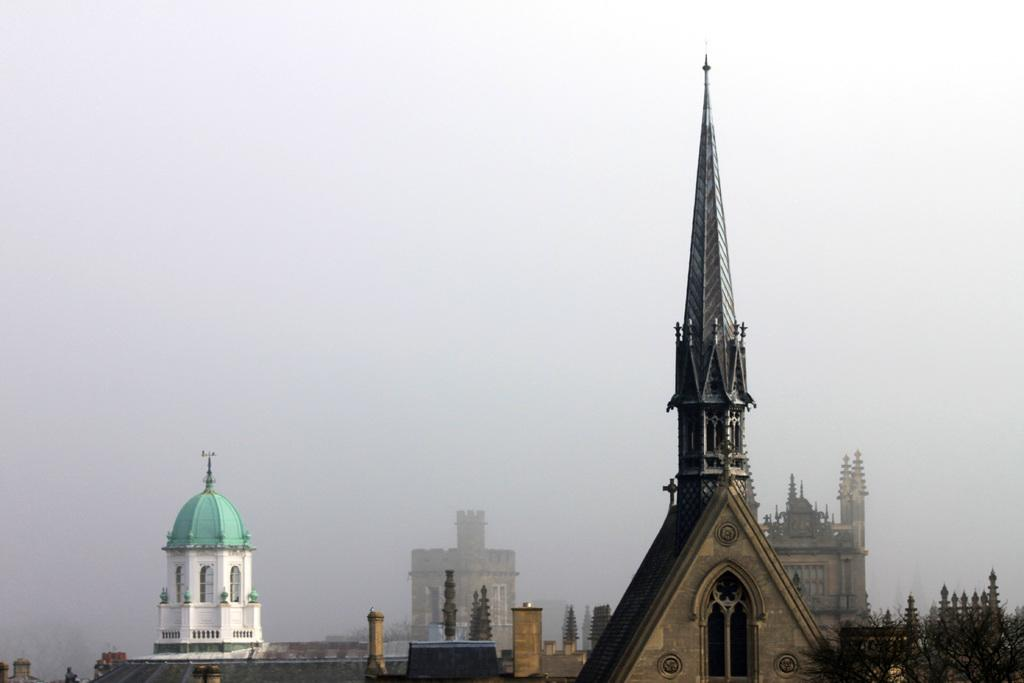What type of structure is the main subject of the image? There is a tower of a church in the image. What other structures can be seen in the image? There are multiple buildings in the image. What is the condition of the sky in the image? The sky is covered with clouds. Can you tell me what time the church tower is flying in the image? There is no indication that the church tower is flying in the image. The tower is a stationary structure, and the concept of time flying is not applicable to this context. 